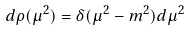Convert formula to latex. <formula><loc_0><loc_0><loc_500><loc_500>d \rho ( \mu ^ { 2 } ) = \delta ( \mu ^ { 2 } - m ^ { 2 } ) d \mu ^ { 2 }</formula> 